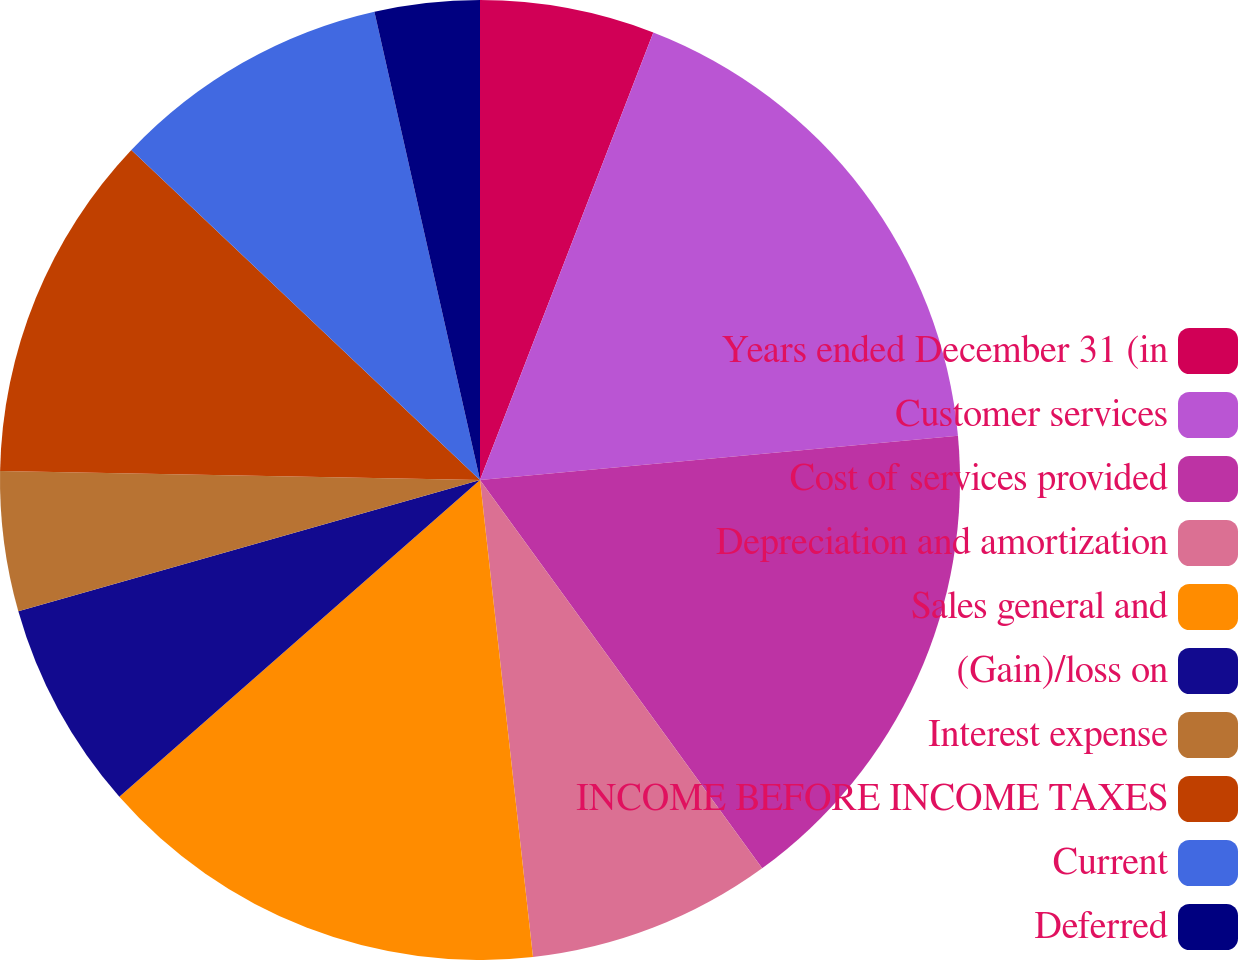Convert chart to OTSL. <chart><loc_0><loc_0><loc_500><loc_500><pie_chart><fcel>Years ended December 31 (in<fcel>Customer services<fcel>Cost of services provided<fcel>Depreciation and amortization<fcel>Sales general and<fcel>(Gain)/loss on<fcel>Interest expense<fcel>INCOME BEFORE INCOME TAXES<fcel>Current<fcel>Deferred<nl><fcel>5.88%<fcel>17.65%<fcel>16.47%<fcel>8.24%<fcel>15.29%<fcel>7.06%<fcel>4.71%<fcel>11.76%<fcel>9.41%<fcel>3.53%<nl></chart> 